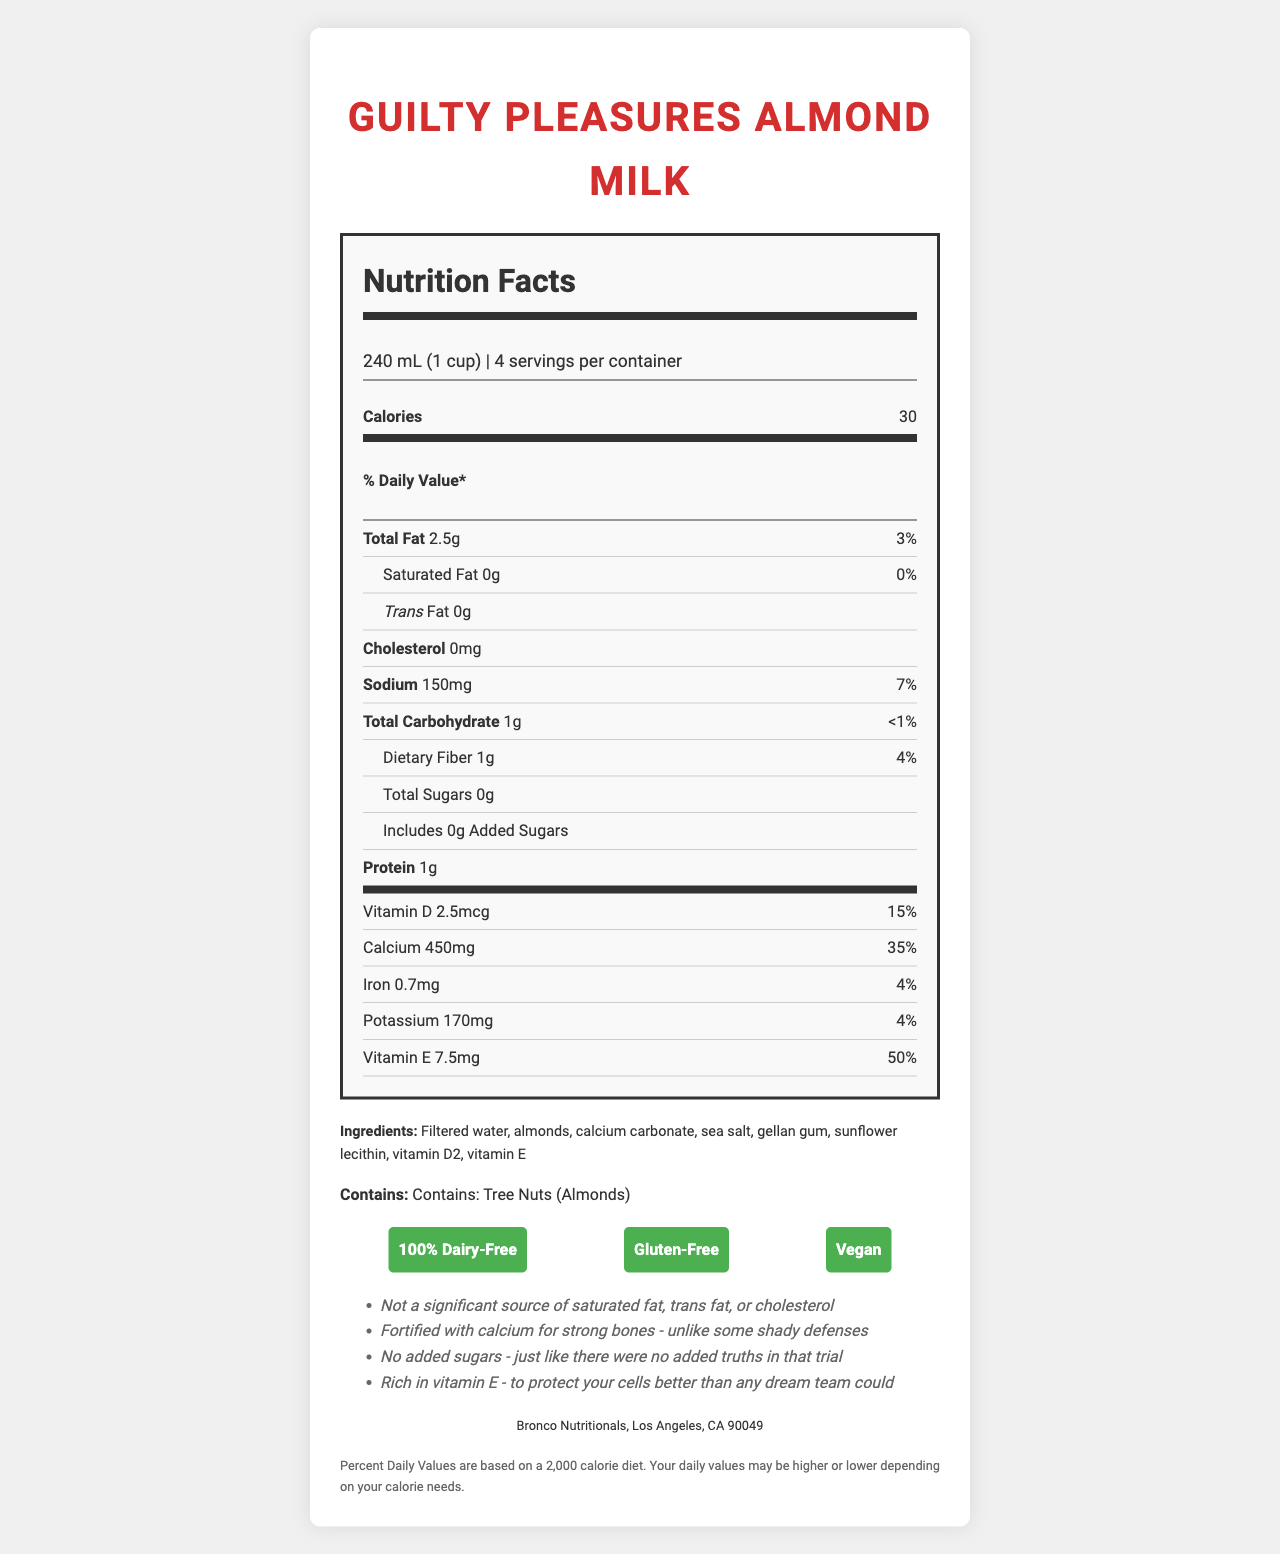What is the serving size for Guilty Pleasures Almond Milk? The serving size is clearly stated at the beginning of the document under the product name and serving information section.
Answer: 240 mL (1 cup) How many calories are in one serving of this almond milk? The calorie count is prominently displayed in the nutrition facts section, right below the serving information.
Answer: 30 calories What percentage of the daily value of Vitamin E does one serving provide? The percentage of the daily value for Vitamin E is listed in the nutrition facts section under the vitamins and minerals.
Answer: 50% What is the amount of calcium in one serving of the almond milk? This amount is specified under the calcium section of the nutrition facts.
Answer: 450mg Is this almond milk gluten-free? The document mentions a gluten-free claim in the claims section below the ingredients.
Answer: Yes How many grams of protein does one serving of Guilty Pleasures Almond Milk provide? A) 0g B) 0.5g C) 1g The amount of protein per serving is shown in the nutrition facts section under protein.
Answer: C) 1g Which of the following claims is NOT listed on the label? A) 100% Dairy-Free B) Organic C) Vegan The document lists 100% Dairy-Free, Gluten-Free, and Vegan claims, but not 'Organic'.
Answer: B) Organic Does the almond milk contain any cholesterol? The document states "0mg" for cholesterol in the nutrition facts section.
Answer: No Summarize the main nutritional benefits highlighted in the document. The summary combines several sections of the document including nutrition facts, claims, and additional information.
Answer: The document emphasizes that Guilty Pleasures Almond Milk is low in calories, provides 2.5g of total fat with no saturated fat, no cholesterol, and is fortified with calcium for bone health. Additionally, it contains no added sugars, is rich in Vitamin E and is dairy-free, gluten-free, and vegan. What is the source of Vitamin D in the almond milk? The document lists Vitamin D2 as an ingredient but does not specify the source.
Answer: Not enough information How much sodium is in a serving of this almond milk? The amount of sodium is listed under the sodium section in the nutrition facts.
Answer: 150mg What is the total carbohydrate content per serving? The total carbohydrate amount is stated in the nutrition facts under total carbohydrate.
Answer: 1g How many servings are there per container? This information is provided in the serving size information at the top of the nutrition facts.
Answer: 4 servings Can this almond milk be included in a vegan diet? The document contains a "Vegan" claim in the claims section.
Answer: Yes What is the main ingredient in Guilty Pleasures Almond Milk? The ingredients list at the bottom of the document starts with "Filtered water".
Answer: Filtered water 